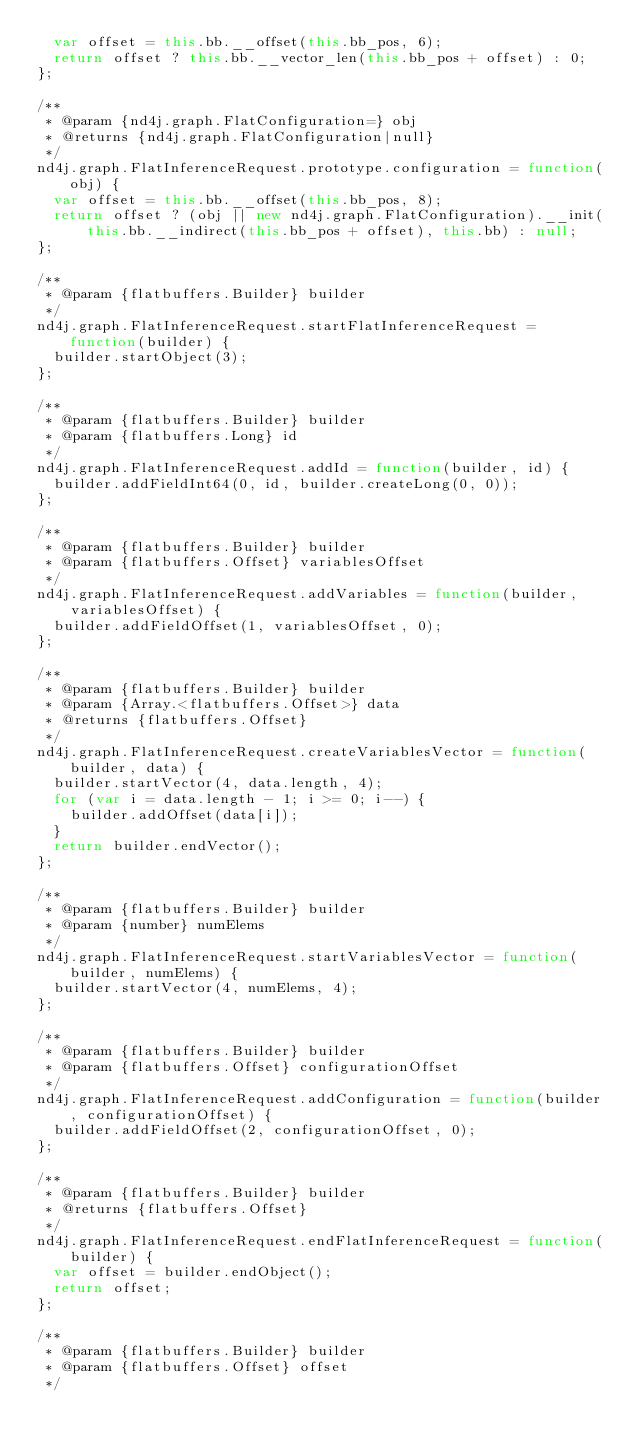<code> <loc_0><loc_0><loc_500><loc_500><_JavaScript_>  var offset = this.bb.__offset(this.bb_pos, 6);
  return offset ? this.bb.__vector_len(this.bb_pos + offset) : 0;
};

/**
 * @param {nd4j.graph.FlatConfiguration=} obj
 * @returns {nd4j.graph.FlatConfiguration|null}
 */
nd4j.graph.FlatInferenceRequest.prototype.configuration = function(obj) {
  var offset = this.bb.__offset(this.bb_pos, 8);
  return offset ? (obj || new nd4j.graph.FlatConfiguration).__init(this.bb.__indirect(this.bb_pos + offset), this.bb) : null;
};

/**
 * @param {flatbuffers.Builder} builder
 */
nd4j.graph.FlatInferenceRequest.startFlatInferenceRequest = function(builder) {
  builder.startObject(3);
};

/**
 * @param {flatbuffers.Builder} builder
 * @param {flatbuffers.Long} id
 */
nd4j.graph.FlatInferenceRequest.addId = function(builder, id) {
  builder.addFieldInt64(0, id, builder.createLong(0, 0));
};

/**
 * @param {flatbuffers.Builder} builder
 * @param {flatbuffers.Offset} variablesOffset
 */
nd4j.graph.FlatInferenceRequest.addVariables = function(builder, variablesOffset) {
  builder.addFieldOffset(1, variablesOffset, 0);
};

/**
 * @param {flatbuffers.Builder} builder
 * @param {Array.<flatbuffers.Offset>} data
 * @returns {flatbuffers.Offset}
 */
nd4j.graph.FlatInferenceRequest.createVariablesVector = function(builder, data) {
  builder.startVector(4, data.length, 4);
  for (var i = data.length - 1; i >= 0; i--) {
    builder.addOffset(data[i]);
  }
  return builder.endVector();
};

/**
 * @param {flatbuffers.Builder} builder
 * @param {number} numElems
 */
nd4j.graph.FlatInferenceRequest.startVariablesVector = function(builder, numElems) {
  builder.startVector(4, numElems, 4);
};

/**
 * @param {flatbuffers.Builder} builder
 * @param {flatbuffers.Offset} configurationOffset
 */
nd4j.graph.FlatInferenceRequest.addConfiguration = function(builder, configurationOffset) {
  builder.addFieldOffset(2, configurationOffset, 0);
};

/**
 * @param {flatbuffers.Builder} builder
 * @returns {flatbuffers.Offset}
 */
nd4j.graph.FlatInferenceRequest.endFlatInferenceRequest = function(builder) {
  var offset = builder.endObject();
  return offset;
};

/**
 * @param {flatbuffers.Builder} builder
 * @param {flatbuffers.Offset} offset
 */</code> 